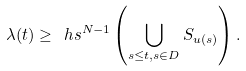<formula> <loc_0><loc_0><loc_500><loc_500>\lambda ( t ) \geq \ h s ^ { N - 1 } \left ( \bigcup _ { s \leq t , s \in D } S _ { u ( s ) } \right ) .</formula> 